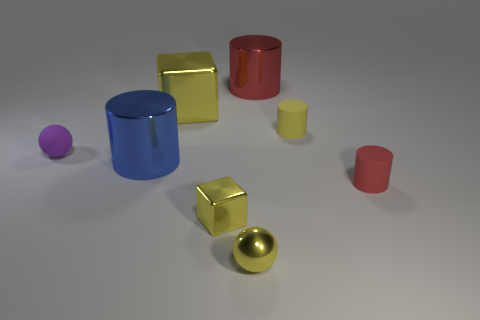Are there more circular objects or square objects in the scene? In the scene, there is a balance between circular and square objects. Each shape category includes three objects: the circular ones are the small pink cup, the blue cylinder, and the yellow sphere, while the square ones consist of the red, blue, and gold cubes. Do any of the objects share the same size and shape? Yes, the blue and red cubes share the same dimensions and shape, each with an equally proportioned cubic structure. 